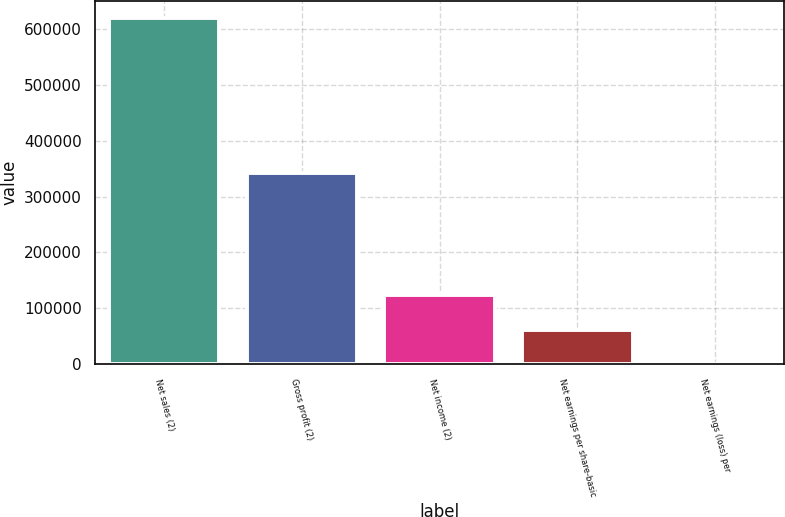Convert chart to OTSL. <chart><loc_0><loc_0><loc_500><loc_500><bar_chart><fcel>Net sales (2)<fcel>Gross profit (2)<fcel>Net income (2)<fcel>Net earnings per share-basic<fcel>Net earnings (loss) per<nl><fcel>619030<fcel>341617<fcel>123807<fcel>61904.3<fcel>1.49<nl></chart> 